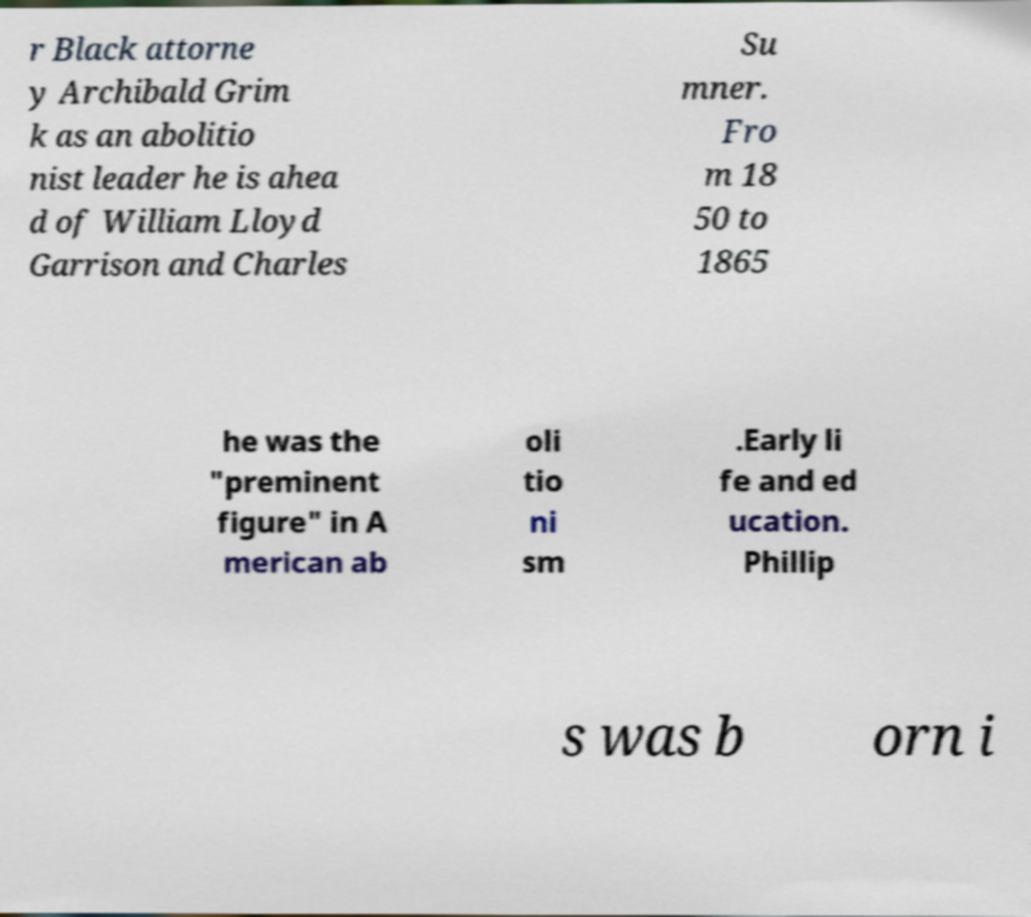Could you extract and type out the text from this image? r Black attorne y Archibald Grim k as an abolitio nist leader he is ahea d of William Lloyd Garrison and Charles Su mner. Fro m 18 50 to 1865 he was the "preminent figure" in A merican ab oli tio ni sm .Early li fe and ed ucation. Phillip s was b orn i 